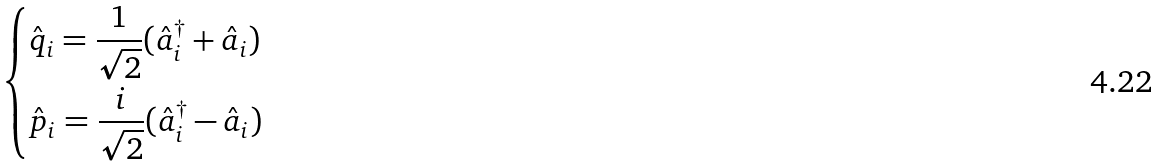<formula> <loc_0><loc_0><loc_500><loc_500>\begin{dcases} \hat { q } _ { i } = \frac { 1 } { \sqrt { 2 } } ( \hat { a } ^ { \dagger } _ { i } + \hat { a } _ { i } ) \\ \hat { p } _ { i } = \frac { i } { \sqrt { 2 } } ( \hat { a } ^ { \dagger } _ { i } - \hat { a } _ { i } ) \end{dcases}</formula> 